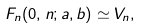Convert formula to latex. <formula><loc_0><loc_0><loc_500><loc_500>F _ { n } ( 0 , n ; a , b ) \simeq V _ { n } ,</formula> 